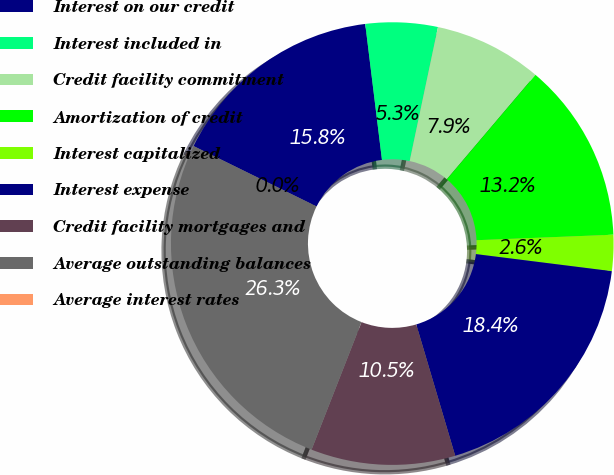Convert chart. <chart><loc_0><loc_0><loc_500><loc_500><pie_chart><fcel>Interest on our credit<fcel>Interest included in<fcel>Credit facility commitment<fcel>Amortization of credit<fcel>Interest capitalized<fcel>Interest expense<fcel>Credit facility mortgages and<fcel>Average outstanding balances<fcel>Average interest rates<nl><fcel>15.79%<fcel>5.26%<fcel>7.89%<fcel>13.16%<fcel>2.63%<fcel>18.42%<fcel>10.53%<fcel>26.32%<fcel>0.0%<nl></chart> 